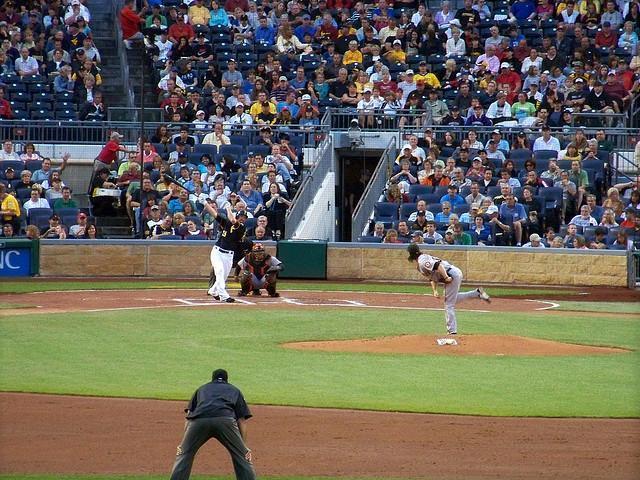What does the man in the center of the field want to achieve?
Select the correct answer and articulate reasoning with the following format: 'Answer: answer
Rationale: rationale.'
Options: Home run, walk, foul, strike. Answer: strike.
Rationale: He wants the other player to strike out. 